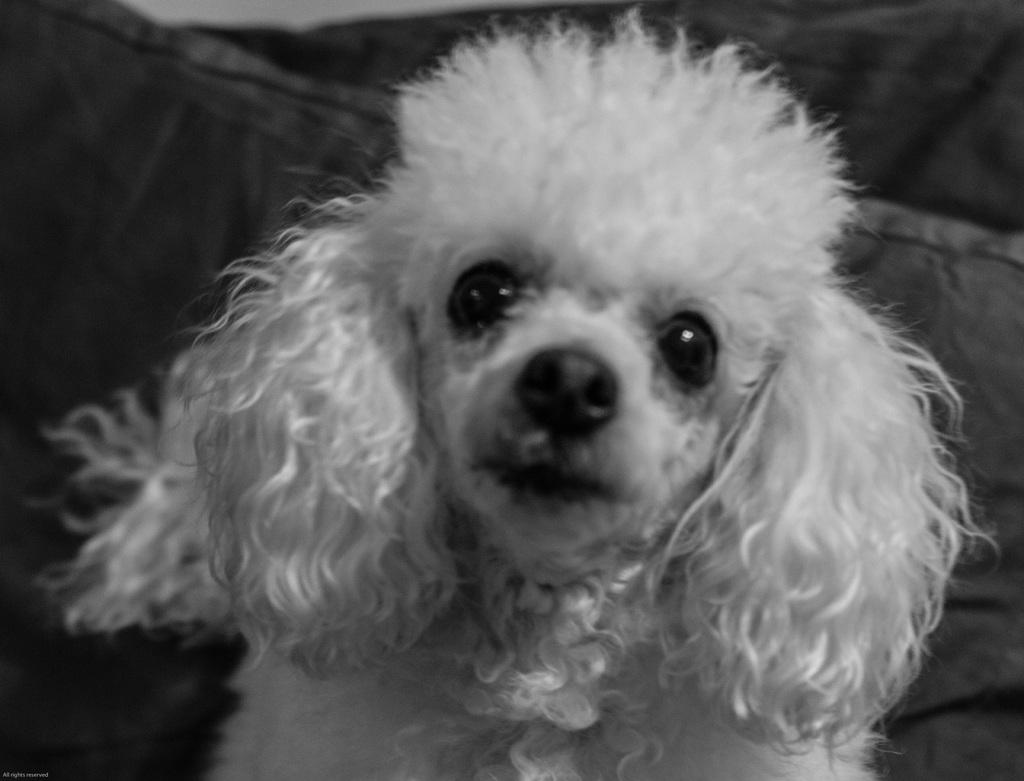What is the color scheme of the image? The image is black and white. What is the main subject of the image? There is a puppy in the middle of the image. What can be seen in the background of the image? There is a cushion in the background of the image. What type of school can be seen in the background of the image? There is no school present in the image; it is a black and white image featuring a puppy and a cushion. 